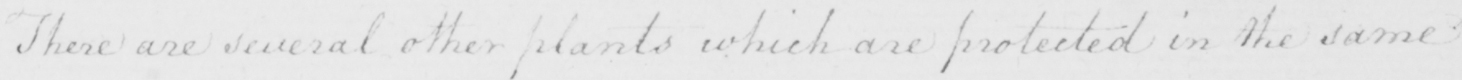Please transcribe the handwritten text in this image. There are several other plants which are protected in the same 